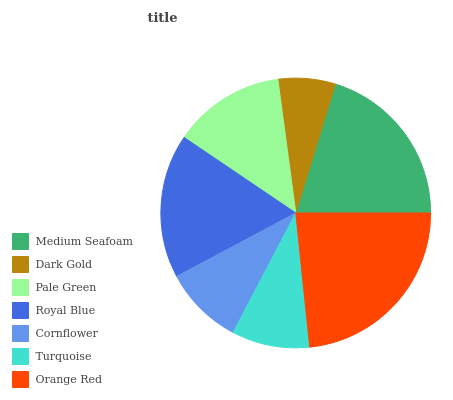Is Dark Gold the minimum?
Answer yes or no. Yes. Is Orange Red the maximum?
Answer yes or no. Yes. Is Pale Green the minimum?
Answer yes or no. No. Is Pale Green the maximum?
Answer yes or no. No. Is Pale Green greater than Dark Gold?
Answer yes or no. Yes. Is Dark Gold less than Pale Green?
Answer yes or no. Yes. Is Dark Gold greater than Pale Green?
Answer yes or no. No. Is Pale Green less than Dark Gold?
Answer yes or no. No. Is Pale Green the high median?
Answer yes or no. Yes. Is Pale Green the low median?
Answer yes or no. Yes. Is Dark Gold the high median?
Answer yes or no. No. Is Royal Blue the low median?
Answer yes or no. No. 